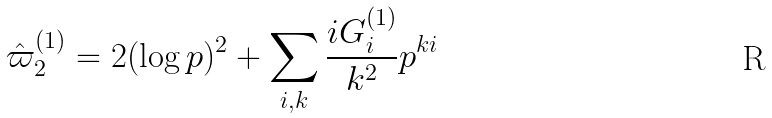Convert formula to latex. <formula><loc_0><loc_0><loc_500><loc_500>\hat { \varpi } ^ { ( 1 ) } _ { 2 } = 2 ( \log p ) ^ { 2 } + \sum _ { i , k } \frac { i G ^ { ( 1 ) } _ { i } } { k ^ { 2 } } p ^ { k i }</formula> 